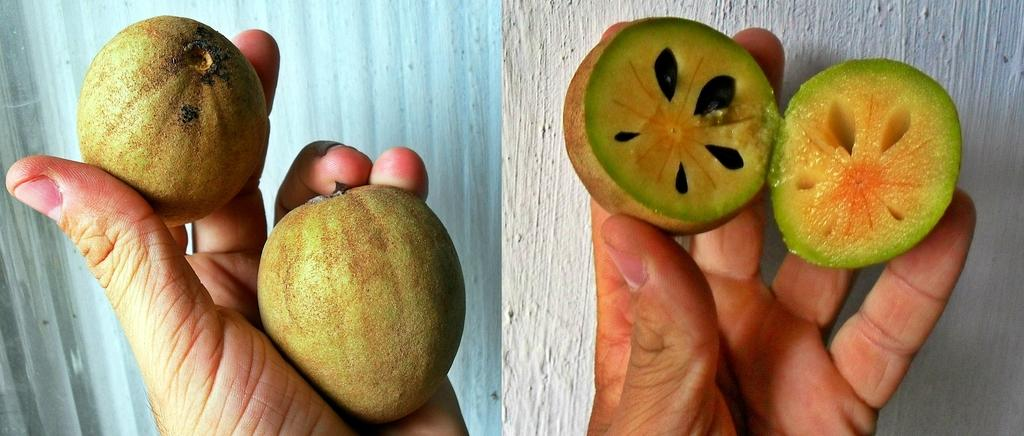What type of image is shown in the picture? The image is a photo grid. Can you describe the main subject in the image? There is a person in the image. What is the person holding in the image? The person is holding a sapota. How many kittens can be seen playing with the sapota in the image? There are no kittens present in the image, and the person is holding the sapota, not playing with it. 